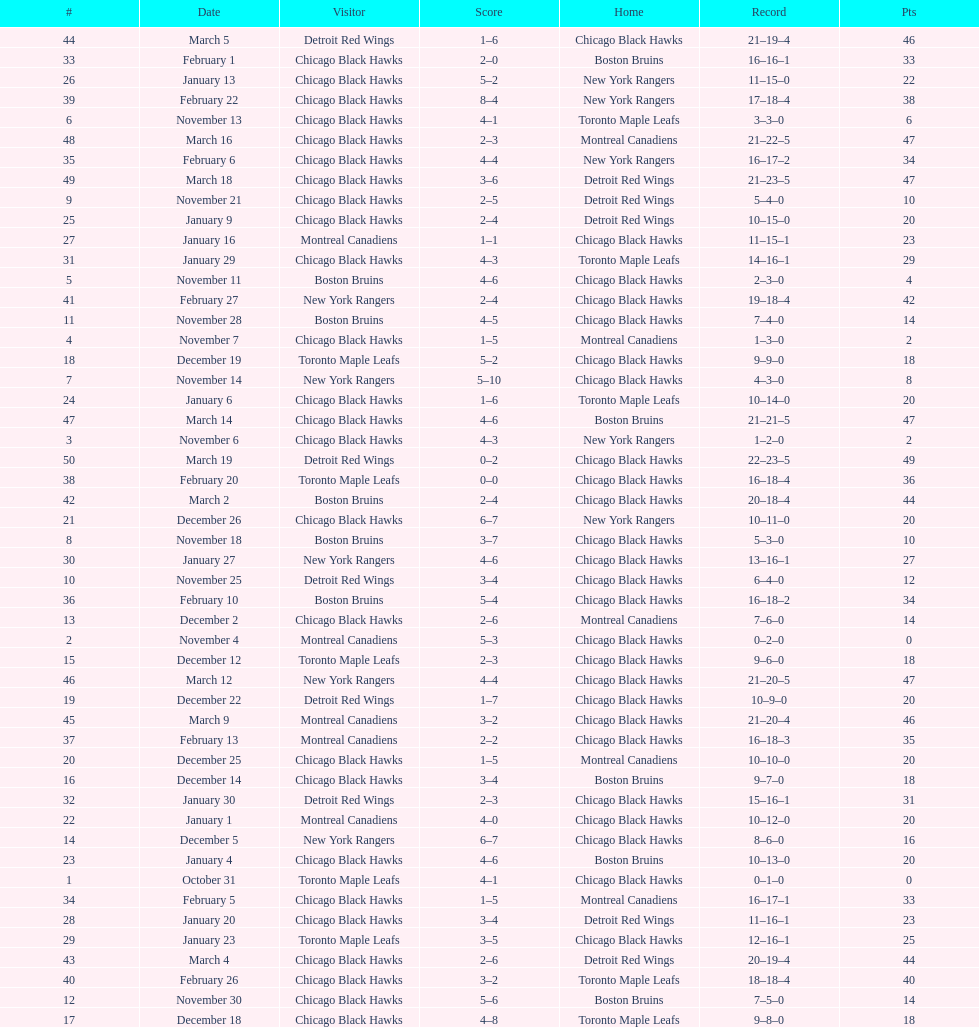Help me parse the entirety of this table. {'header': ['#', 'Date', 'Visitor', 'Score', 'Home', 'Record', 'Pts'], 'rows': [['44', 'March 5', 'Detroit Red Wings', '1–6', 'Chicago Black Hawks', '21–19–4', '46'], ['33', 'February 1', 'Chicago Black Hawks', '2–0', 'Boston Bruins', '16–16–1', '33'], ['26', 'January 13', 'Chicago Black Hawks', '5–2', 'New York Rangers', '11–15–0', '22'], ['39', 'February 22', 'Chicago Black Hawks', '8–4', 'New York Rangers', '17–18–4', '38'], ['6', 'November 13', 'Chicago Black Hawks', '4–1', 'Toronto Maple Leafs', '3–3–0', '6'], ['48', 'March 16', 'Chicago Black Hawks', '2–3', 'Montreal Canadiens', '21–22–5', '47'], ['35', 'February 6', 'Chicago Black Hawks', '4–4', 'New York Rangers', '16–17–2', '34'], ['49', 'March 18', 'Chicago Black Hawks', '3–6', 'Detroit Red Wings', '21–23–5', '47'], ['9', 'November 21', 'Chicago Black Hawks', '2–5', 'Detroit Red Wings', '5–4–0', '10'], ['25', 'January 9', 'Chicago Black Hawks', '2–4', 'Detroit Red Wings', '10–15–0', '20'], ['27', 'January 16', 'Montreal Canadiens', '1–1', 'Chicago Black Hawks', '11–15–1', '23'], ['31', 'January 29', 'Chicago Black Hawks', '4–3', 'Toronto Maple Leafs', '14–16–1', '29'], ['5', 'November 11', 'Boston Bruins', '4–6', 'Chicago Black Hawks', '2–3–0', '4'], ['41', 'February 27', 'New York Rangers', '2–4', 'Chicago Black Hawks', '19–18–4', '42'], ['11', 'November 28', 'Boston Bruins', '4–5', 'Chicago Black Hawks', '7–4–0', '14'], ['4', 'November 7', 'Chicago Black Hawks', '1–5', 'Montreal Canadiens', '1–3–0', '2'], ['18', 'December 19', 'Toronto Maple Leafs', '5–2', 'Chicago Black Hawks', '9–9–0', '18'], ['7', 'November 14', 'New York Rangers', '5–10', 'Chicago Black Hawks', '4–3–0', '8'], ['24', 'January 6', 'Chicago Black Hawks', '1–6', 'Toronto Maple Leafs', '10–14–0', '20'], ['47', 'March 14', 'Chicago Black Hawks', '4–6', 'Boston Bruins', '21–21–5', '47'], ['3', 'November 6', 'Chicago Black Hawks', '4–3', 'New York Rangers', '1–2–0', '2'], ['50', 'March 19', 'Detroit Red Wings', '0–2', 'Chicago Black Hawks', '22–23–5', '49'], ['38', 'February 20', 'Toronto Maple Leafs', '0–0', 'Chicago Black Hawks', '16–18–4', '36'], ['42', 'March 2', 'Boston Bruins', '2–4', 'Chicago Black Hawks', '20–18–4', '44'], ['21', 'December 26', 'Chicago Black Hawks', '6–7', 'New York Rangers', '10–11–0', '20'], ['8', 'November 18', 'Boston Bruins', '3–7', 'Chicago Black Hawks', '5–3–0', '10'], ['30', 'January 27', 'New York Rangers', '4–6', 'Chicago Black Hawks', '13–16–1', '27'], ['10', 'November 25', 'Detroit Red Wings', '3–4', 'Chicago Black Hawks', '6–4–0', '12'], ['36', 'February 10', 'Boston Bruins', '5–4', 'Chicago Black Hawks', '16–18–2', '34'], ['13', 'December 2', 'Chicago Black Hawks', '2–6', 'Montreal Canadiens', '7–6–0', '14'], ['2', 'November 4', 'Montreal Canadiens', '5–3', 'Chicago Black Hawks', '0–2–0', '0'], ['15', 'December 12', 'Toronto Maple Leafs', '2–3', 'Chicago Black Hawks', '9–6–0', '18'], ['46', 'March 12', 'New York Rangers', '4–4', 'Chicago Black Hawks', '21–20–5', '47'], ['19', 'December 22', 'Detroit Red Wings', '1–7', 'Chicago Black Hawks', '10–9–0', '20'], ['45', 'March 9', 'Montreal Canadiens', '3–2', 'Chicago Black Hawks', '21–20–4', '46'], ['37', 'February 13', 'Montreal Canadiens', '2–2', 'Chicago Black Hawks', '16–18–3', '35'], ['20', 'December 25', 'Chicago Black Hawks', '1–5', 'Montreal Canadiens', '10–10–0', '20'], ['16', 'December 14', 'Chicago Black Hawks', '3–4', 'Boston Bruins', '9–7–0', '18'], ['32', 'January 30', 'Detroit Red Wings', '2–3', 'Chicago Black Hawks', '15–16–1', '31'], ['22', 'January 1', 'Montreal Canadiens', '4–0', 'Chicago Black Hawks', '10–12–0', '20'], ['14', 'December 5', 'New York Rangers', '6–7', 'Chicago Black Hawks', '8–6–0', '16'], ['23', 'January 4', 'Chicago Black Hawks', '4–6', 'Boston Bruins', '10–13–0', '20'], ['1', 'October 31', 'Toronto Maple Leafs', '4–1', 'Chicago Black Hawks', '0–1–0', '0'], ['34', 'February 5', 'Chicago Black Hawks', '1–5', 'Montreal Canadiens', '16–17–1', '33'], ['28', 'January 20', 'Chicago Black Hawks', '3–4', 'Detroit Red Wings', '11–16–1', '23'], ['29', 'January 23', 'Toronto Maple Leafs', '3–5', 'Chicago Black Hawks', '12–16–1', '25'], ['43', 'March 4', 'Chicago Black Hawks', '2–6', 'Detroit Red Wings', '20–19–4', '44'], ['40', 'February 26', 'Chicago Black Hawks', '3–2', 'Toronto Maple Leafs', '18–18–4', '40'], ['12', 'November 30', 'Chicago Black Hawks', '5–6', 'Boston Bruins', '7–5–0', '14'], ['17', 'December 18', 'Chicago Black Hawks', '4–8', 'Toronto Maple Leafs', '9–8–0', '18']]} What is the difference in pts between december 5th and november 11th? 3. 